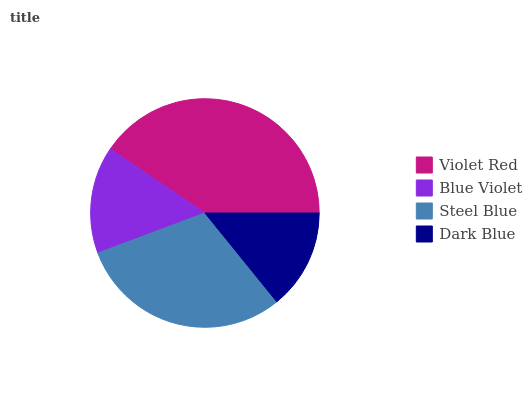Is Dark Blue the minimum?
Answer yes or no. Yes. Is Violet Red the maximum?
Answer yes or no. Yes. Is Blue Violet the minimum?
Answer yes or no. No. Is Blue Violet the maximum?
Answer yes or no. No. Is Violet Red greater than Blue Violet?
Answer yes or no. Yes. Is Blue Violet less than Violet Red?
Answer yes or no. Yes. Is Blue Violet greater than Violet Red?
Answer yes or no. No. Is Violet Red less than Blue Violet?
Answer yes or no. No. Is Steel Blue the high median?
Answer yes or no. Yes. Is Blue Violet the low median?
Answer yes or no. Yes. Is Dark Blue the high median?
Answer yes or no. No. Is Steel Blue the low median?
Answer yes or no. No. 